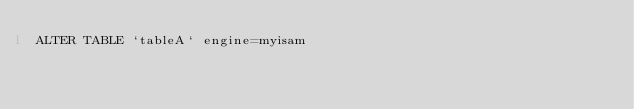Convert code to text. <code><loc_0><loc_0><loc_500><loc_500><_SQL_>ALTER TABLE `tableA` engine=myisam</code> 